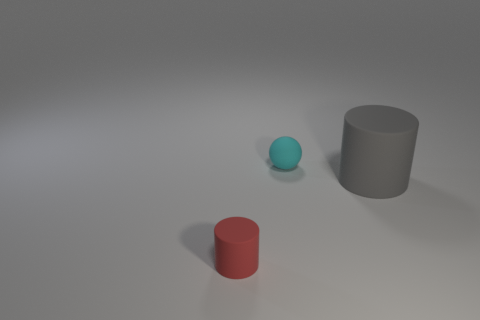Add 2 large gray matte cylinders. How many objects exist? 5 Subtract all balls. How many objects are left? 2 Add 3 blue matte objects. How many blue matte objects exist? 3 Subtract 0 yellow cylinders. How many objects are left? 3 Subtract all gray rubber cylinders. Subtract all small cyan rubber balls. How many objects are left? 1 Add 1 small red objects. How many small red objects are left? 2 